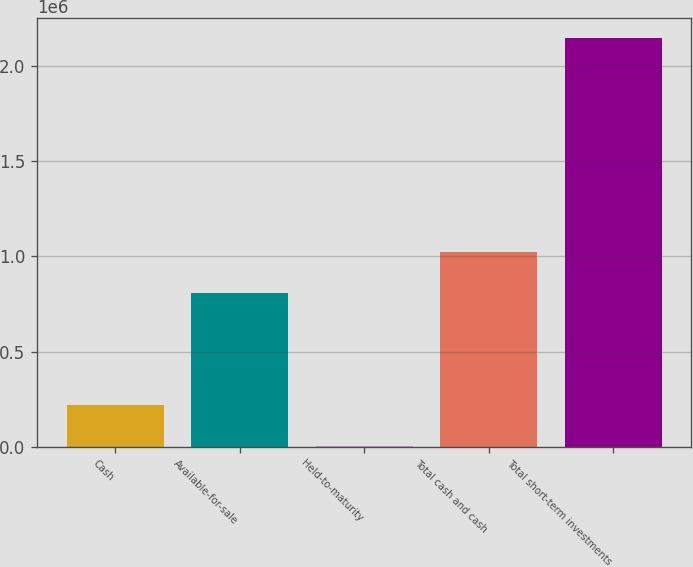Convert chart to OTSL. <chart><loc_0><loc_0><loc_500><loc_500><bar_chart><fcel>Cash<fcel>Available-for-sale<fcel>Held-to-maturity<fcel>Total cash and cash<fcel>Total short-term investments<nl><fcel>217860<fcel>807935<fcel>3780<fcel>1.02201e+06<fcel>2.14458e+06<nl></chart> 